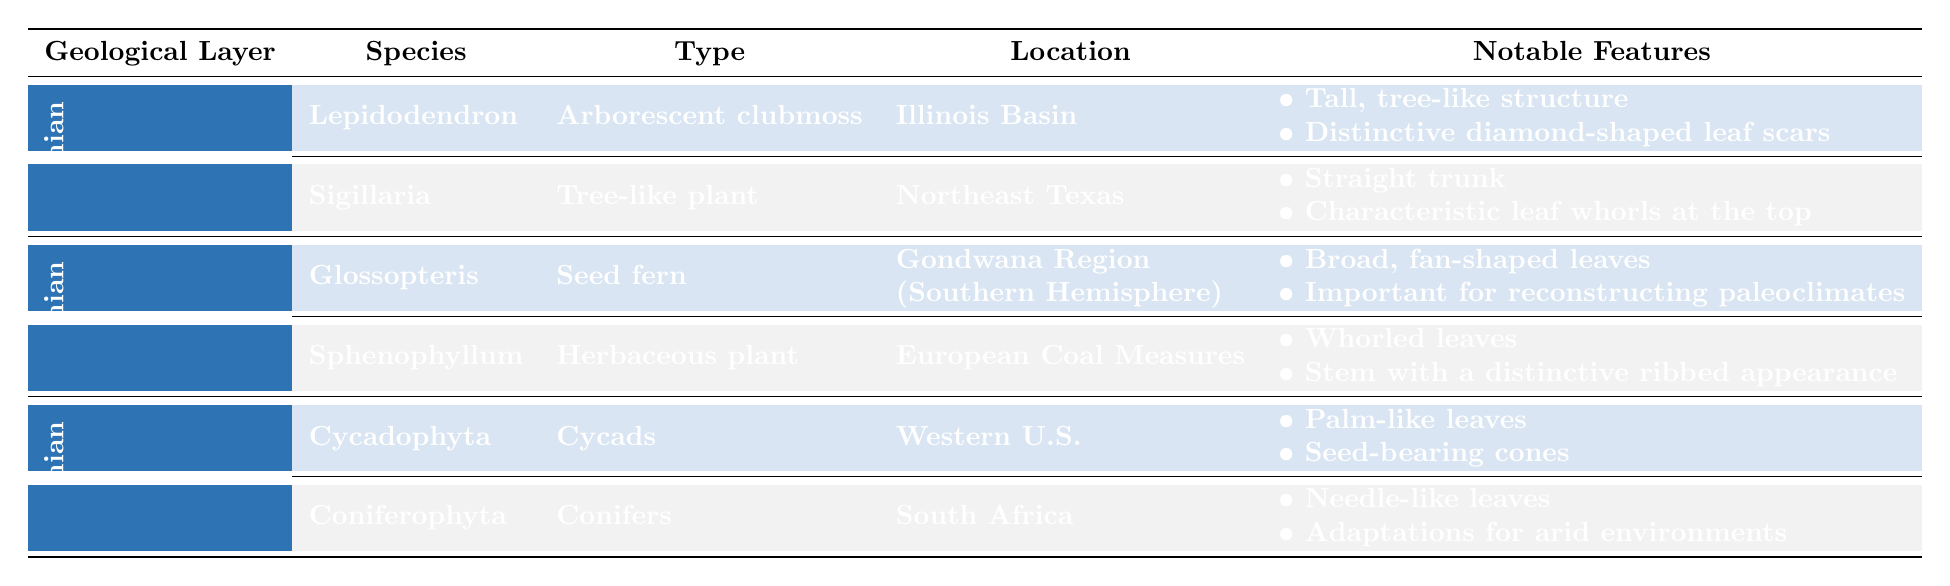What is the species found in the Upper Permian layer? The table indicates that there are two species listed under the Upper Permian layer: Cycadophyta and Coniferophyta.
Answer: Cycadophyta and Coniferophyta Which plant type has broad, fan-shaped leaves? Looking at the Middle Permian layer, the species Glossopteris is identified as having broad, fan-shaped leaves.
Answer: Glossopteris How many different species of fossilized plant remains are found in the Lower Permian layer? In the Lower Permian layer, there are two species of fossilized plant remains listed: Lepidodendron and Sigillaria.
Answer: 2 Is Sphenophyllum a type of seed fern? The table indicates that Sphenophyllum is classified as an herbaceous plant, and thus it is not a seed fern.
Answer: No What notable features are shared between Lepidodendron and Sigillaria? The notable features show that both species have structural elements that contribute to their tree-like characteristics, but they do not share any features as they are distinct.
Answer: None What is the main location where Glossopteris was found? The table shows that Glossopteris was located in the Gondwana Region (Southern Hemisphere).
Answer: Gondwana Region (Southern Hemisphere) Which geological layer has the most distinct adaptations for arid environments? The Upper Permian layer has Coniferophyta, which is noted for its adaptations for arid environments, indicating it is well-suited for such conditions.
Answer: Upper Permian List one notable feature of Cycadophyta. The table indicates that a notable feature of Cycadophyta is its palm-like leaves.
Answer: Palm-like leaves What is the primary family for the species Lepidodendron? According to the table, Lepidodendron belongs to the family Lepidodendraceae.
Answer: Lepidodendraceae 